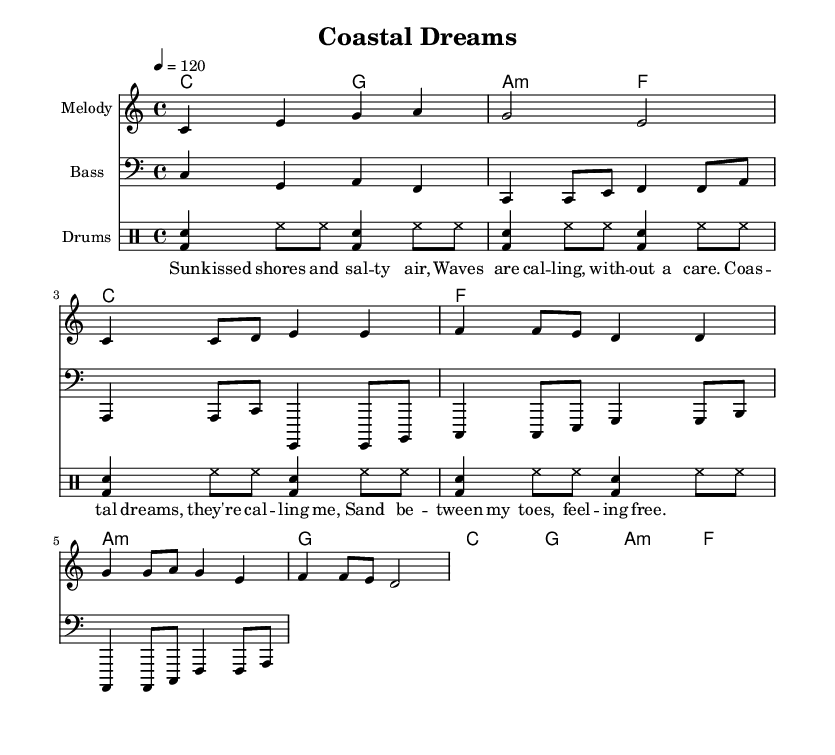What is the key signature of this music? The key signature is C major, which has no sharps or flats.
Answer: C major What is the time signature of this music? The time signature is noted right next to the clef at the beginning, indicating the number of beats in each measure. Here, it shows 4 beats per measure.
Answer: 4/4 What is the tempo marking of this piece? The tempo is indicated at the beginning with "4 = 120", specifying that there are 120 beats per minute.
Answer: 120 What is the instrument used for the melody? The instrument for the melody is specified in the staff title, which is shown above the staff in the sheet music. It states "Melody".
Answer: Melody How many measures are there in the chorus section? By analyzing the score, you can count the measures specifically marked for the chorus, where distinct lyrics are provided. There are 4 measures in the chorus.
Answer: 4 What type of chord follows the "a" chord in the verse? The chord progression in the verse can be observed immediately after the a minor chord, which transitions into the g major chord next.
Answer: g Which lyric line contains the word "dreams"? By reviewing the lyrics section, the word “dreams” is found in the second lyric line, which discusses "Coastal dreams".
Answer: Coastal dreams 